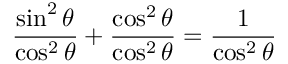<formula> <loc_0><loc_0><loc_500><loc_500>{ \frac { \sin ^ { 2 } \theta } { \cos ^ { 2 } \theta } } + { \frac { \cos ^ { 2 } \theta } { \cos ^ { 2 } \theta } } = { \frac { 1 } { \cos ^ { 2 } \theta } }</formula> 